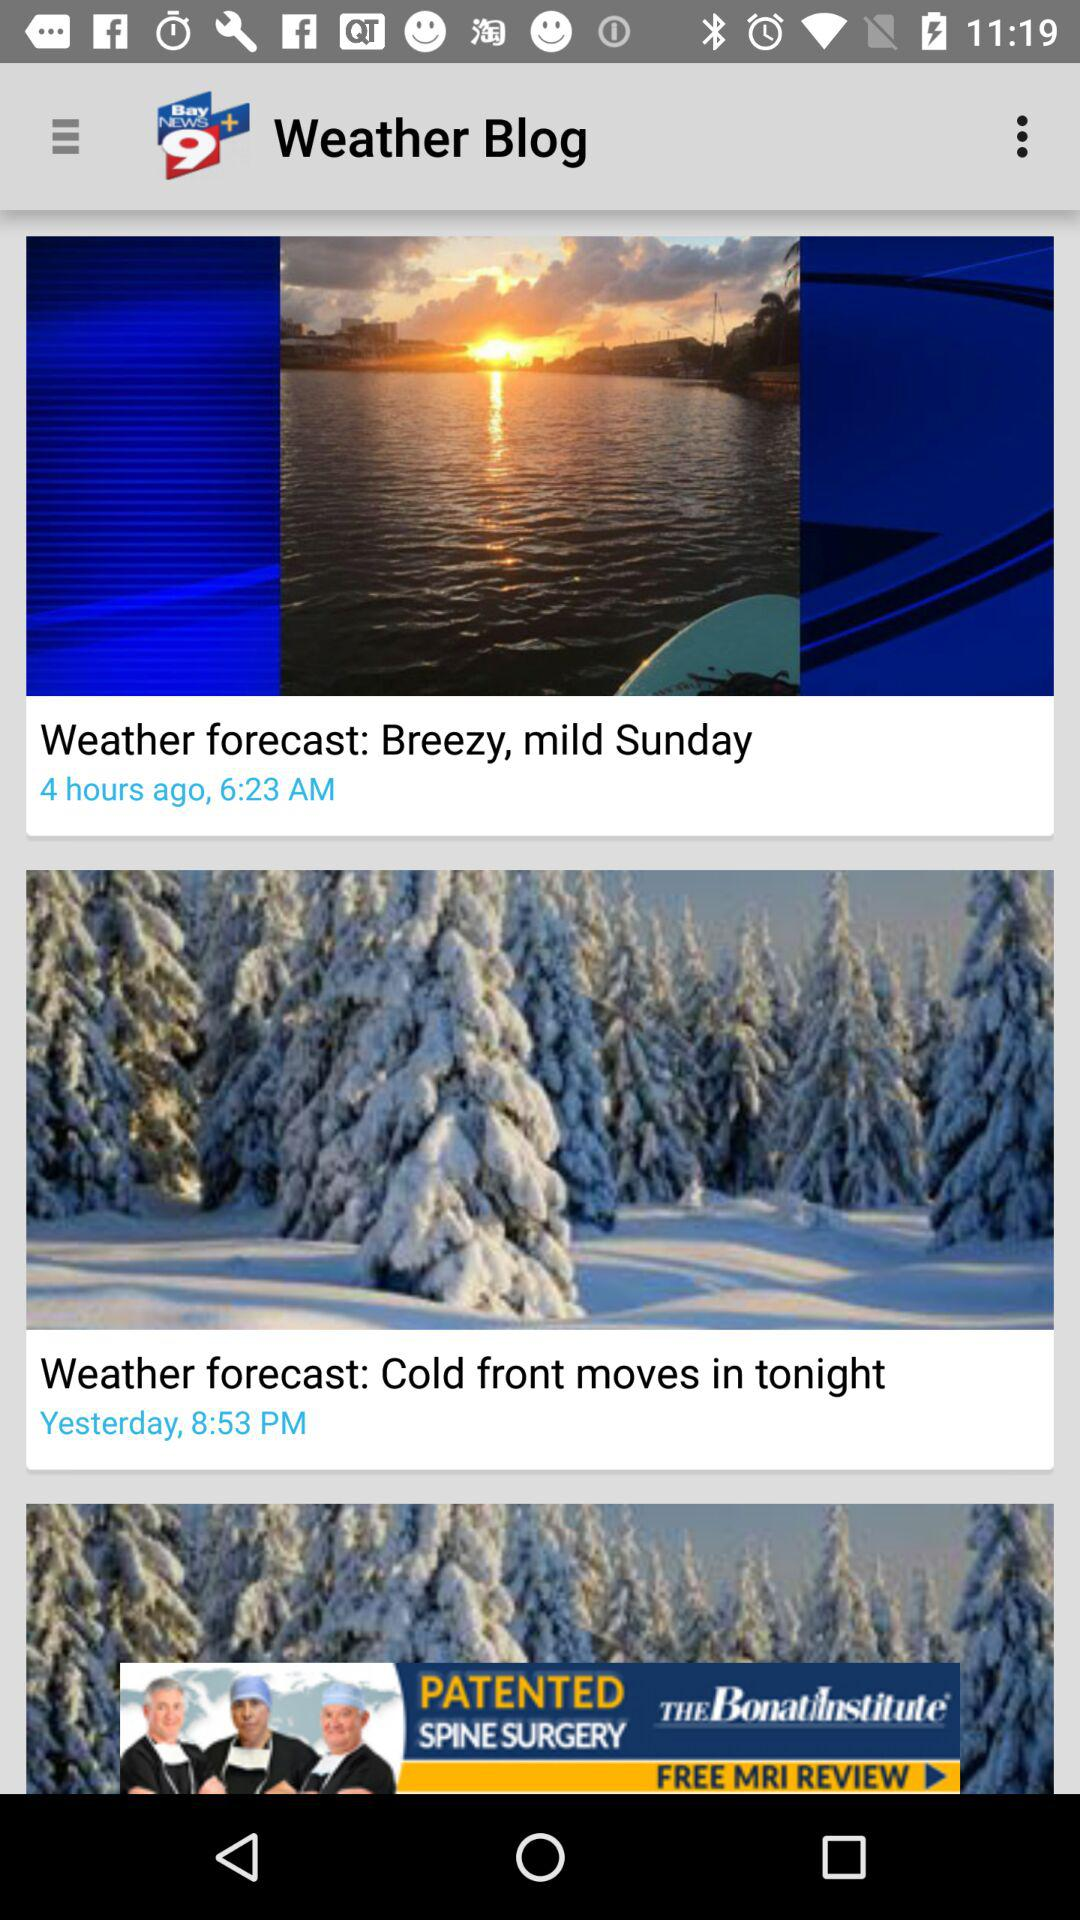What is the weather forecast on yesterday?
When the provided information is insufficient, respond with <no answer>. <no answer> 